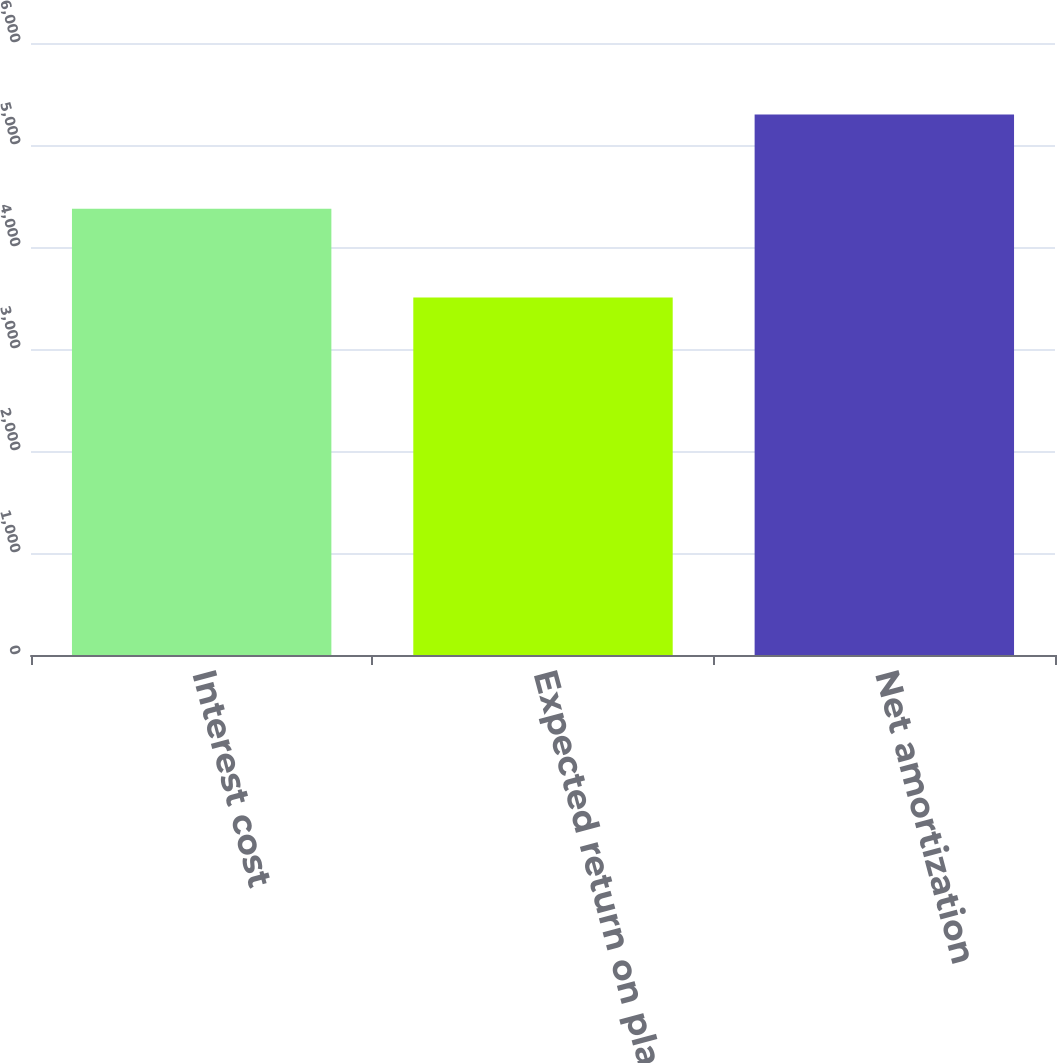Convert chart to OTSL. <chart><loc_0><loc_0><loc_500><loc_500><bar_chart><fcel>Interest cost<fcel>Expected return on plan assets<fcel>Net amortization<nl><fcel>4375<fcel>3505<fcel>5299<nl></chart> 